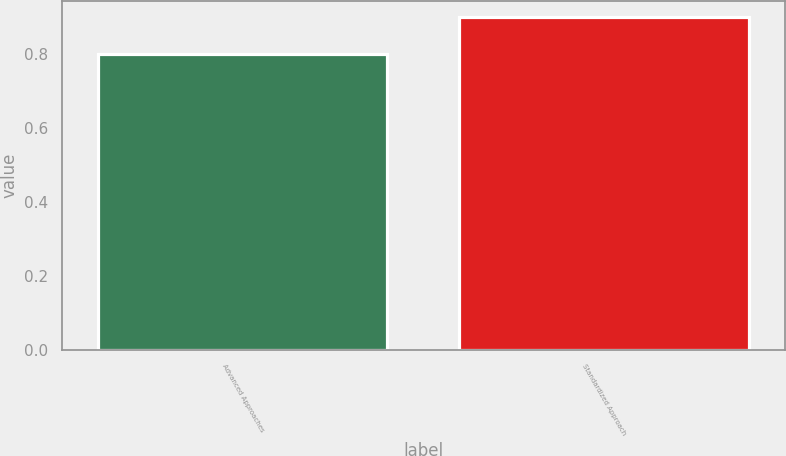Convert chart. <chart><loc_0><loc_0><loc_500><loc_500><bar_chart><fcel>Advanced Approaches<fcel>Standardized Approach<nl><fcel>0.8<fcel>0.9<nl></chart> 